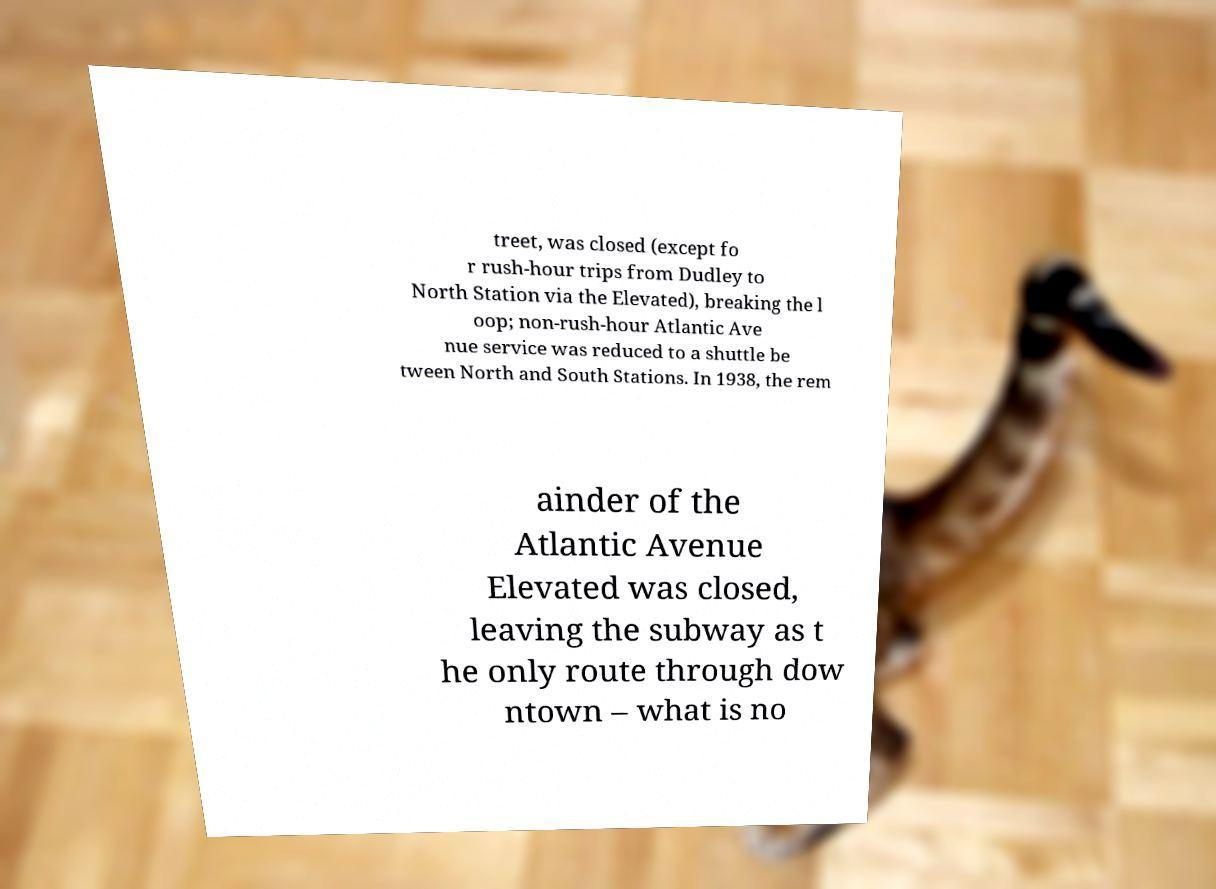Can you read and provide the text displayed in the image?This photo seems to have some interesting text. Can you extract and type it out for me? treet, was closed (except fo r rush-hour trips from Dudley to North Station via the Elevated), breaking the l oop; non-rush-hour Atlantic Ave nue service was reduced to a shuttle be tween North and South Stations. In 1938, the rem ainder of the Atlantic Avenue Elevated was closed, leaving the subway as t he only route through dow ntown – what is no 